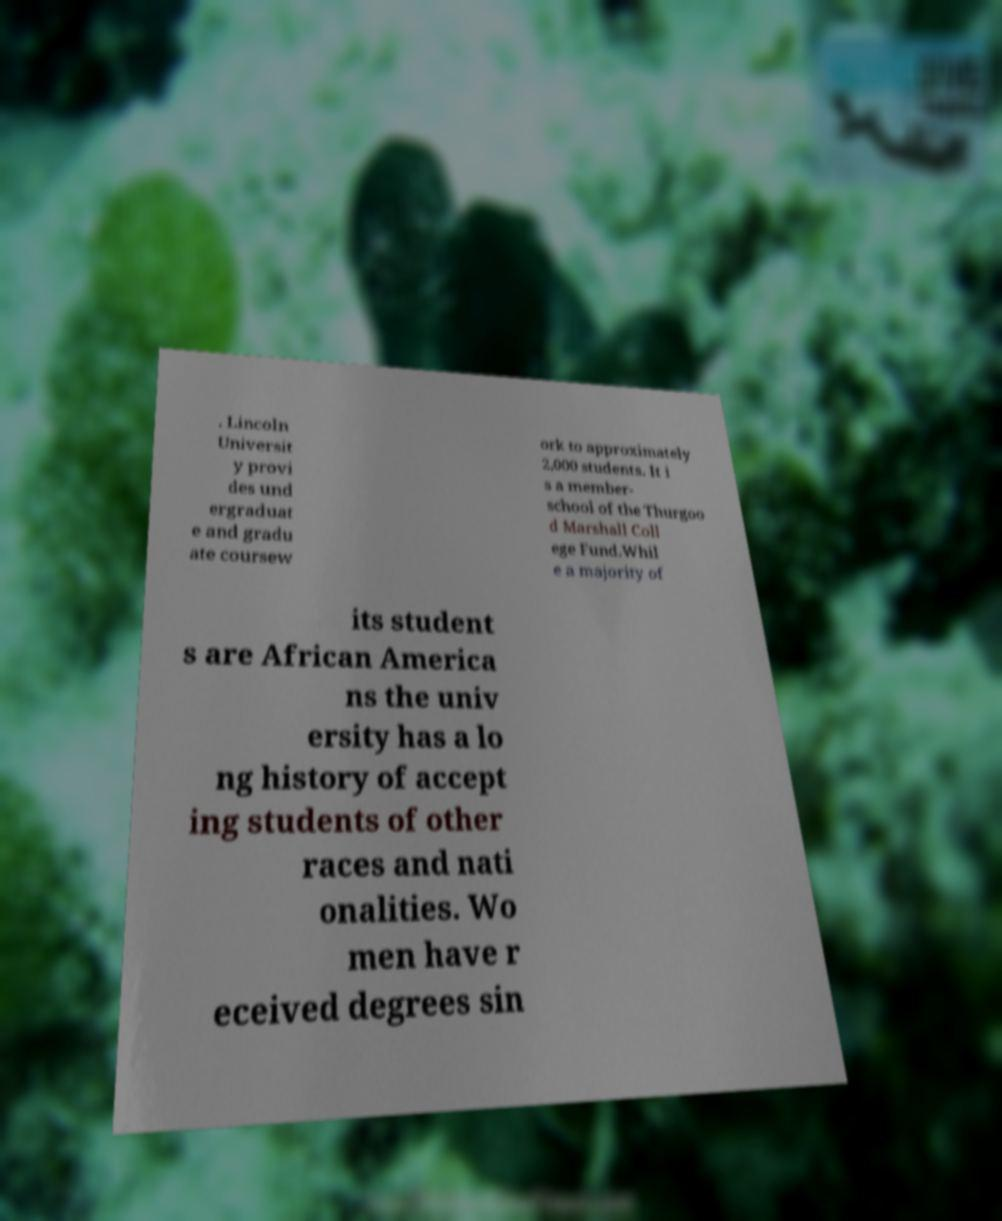There's text embedded in this image that I need extracted. Can you transcribe it verbatim? . Lincoln Universit y provi des und ergraduat e and gradu ate coursew ork to approximately 2,000 students. It i s a member- school of the Thurgoo d Marshall Coll ege Fund.Whil e a majority of its student s are African America ns the univ ersity has a lo ng history of accept ing students of other races and nati onalities. Wo men have r eceived degrees sin 